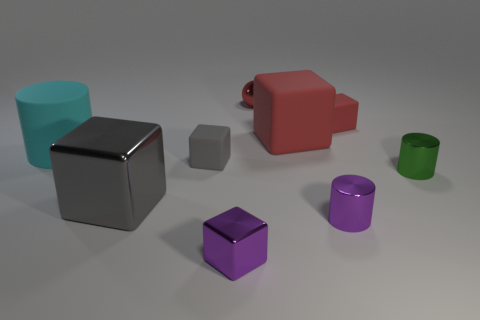Subtract all purple cubes. How many cubes are left? 4 Subtract all gray shiny cubes. How many cubes are left? 4 Subtract all green blocks. Subtract all gray cylinders. How many blocks are left? 5 Add 1 red metallic objects. How many objects exist? 10 Subtract all blocks. How many objects are left? 4 Add 7 metal balls. How many metal balls are left? 8 Add 1 tiny yellow objects. How many tiny yellow objects exist? 1 Subtract 0 red cylinders. How many objects are left? 9 Subtract all small red cylinders. Subtract all big objects. How many objects are left? 6 